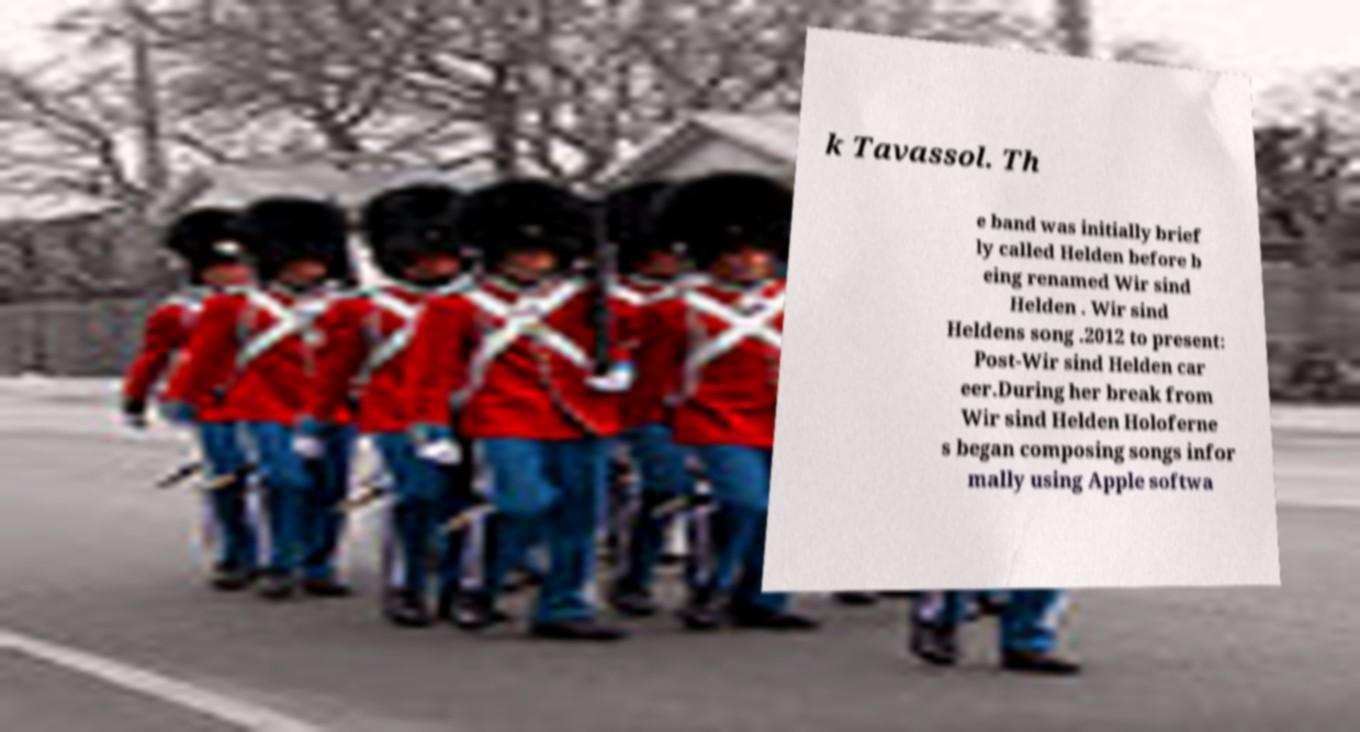Could you extract and type out the text from this image? k Tavassol. Th e band was initially brief ly called Helden before b eing renamed Wir sind Helden . Wir sind Heldens song .2012 to present: Post-Wir sind Helden car eer.During her break from Wir sind Helden Holoferne s began composing songs infor mally using Apple softwa 